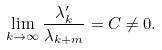Convert formula to latex. <formula><loc_0><loc_0><loc_500><loc_500>\lim _ { k \to \infty } \frac { \lambda ^ { \prime } _ { k } } { \lambda _ { k + m } } = C \not = 0 .</formula> 